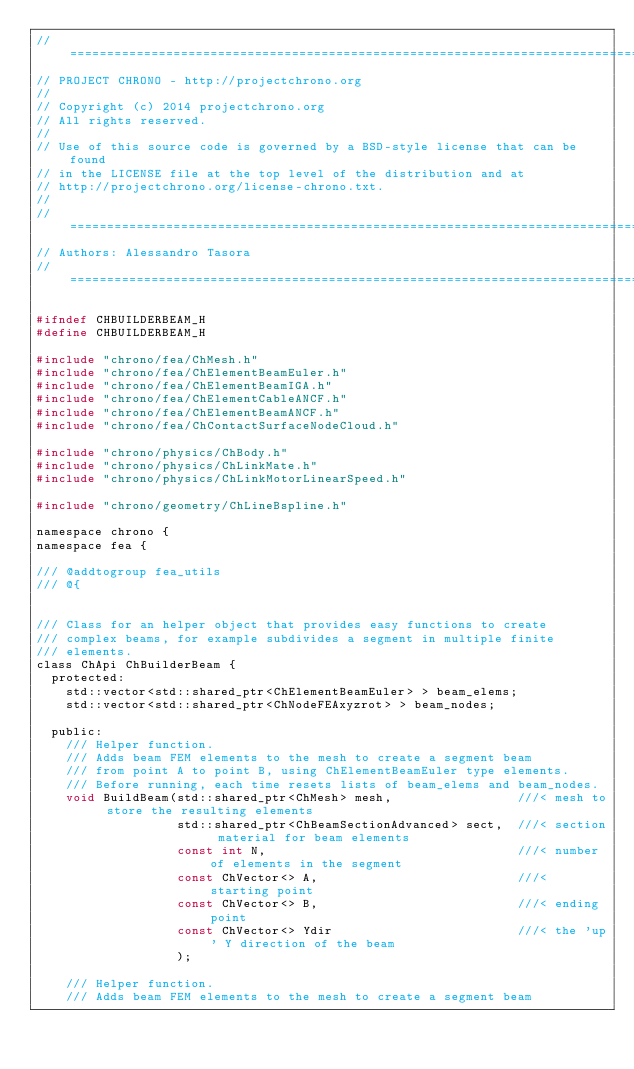<code> <loc_0><loc_0><loc_500><loc_500><_C_>// =============================================================================
// PROJECT CHRONO - http://projectchrono.org
//
// Copyright (c) 2014 projectchrono.org
// All rights reserved.
//
// Use of this source code is governed by a BSD-style license that can be found
// in the LICENSE file at the top level of the distribution and at
// http://projectchrono.org/license-chrono.txt.
//
// =============================================================================
// Authors: Alessandro Tasora
// =============================================================================

#ifndef CHBUILDERBEAM_H
#define CHBUILDERBEAM_H

#include "chrono/fea/ChMesh.h"
#include "chrono/fea/ChElementBeamEuler.h"
#include "chrono/fea/ChElementBeamIGA.h"
#include "chrono/fea/ChElementCableANCF.h"
#include "chrono/fea/ChElementBeamANCF.h"
#include "chrono/fea/ChContactSurfaceNodeCloud.h"

#include "chrono/physics/ChBody.h"
#include "chrono/physics/ChLinkMate.h"
#include "chrono/physics/ChLinkMotorLinearSpeed.h"

#include "chrono/geometry/ChLineBspline.h"

namespace chrono {
namespace fea {

/// @addtogroup fea_utils
/// @{


/// Class for an helper object that provides easy functions to create
/// complex beams, for example subdivides a segment in multiple finite
/// elements.
class ChApi ChBuilderBeam {
  protected:
    std::vector<std::shared_ptr<ChElementBeamEuler> > beam_elems;
    std::vector<std::shared_ptr<ChNodeFEAxyzrot> > beam_nodes;

  public:
    /// Helper function.
    /// Adds beam FEM elements to the mesh to create a segment beam
    /// from point A to point B, using ChElementBeamEuler type elements.
    /// Before running, each time resets lists of beam_elems and beam_nodes.
    void BuildBeam(std::shared_ptr<ChMesh> mesh,                 ///< mesh to store the resulting elements
                   std::shared_ptr<ChBeamSectionAdvanced> sect,  ///< section material for beam elements
                   const int N,                                  ///< number of elements in the segment
                   const ChVector<> A,                           ///< starting point
                   const ChVector<> B,                           ///< ending point
                   const ChVector<> Ydir                         ///< the 'up' Y direction of the beam
                   );

    /// Helper function.
    /// Adds beam FEM elements to the mesh to create a segment beam</code> 